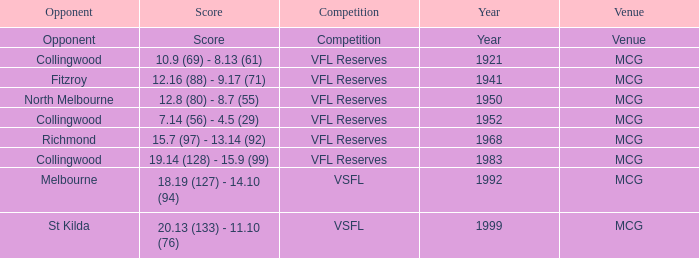In what competition was the score reported as 12.8 (80) - 8.7 (55)? VFL Reserves. 